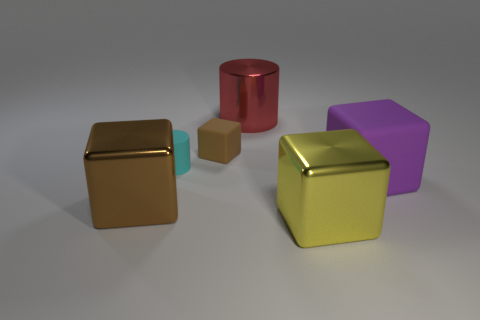Add 1 metal cubes. How many objects exist? 7 Subtract all large brown cubes. How many cubes are left? 3 Subtract all blocks. How many objects are left? 2 Subtract all matte things. Subtract all big shiny cylinders. How many objects are left? 2 Add 1 small cylinders. How many small cylinders are left? 2 Add 3 big cyan objects. How many big cyan objects exist? 3 Subtract all red cylinders. How many cylinders are left? 1 Subtract 0 blue cylinders. How many objects are left? 6 Subtract 3 blocks. How many blocks are left? 1 Subtract all gray cylinders. Subtract all cyan blocks. How many cylinders are left? 2 